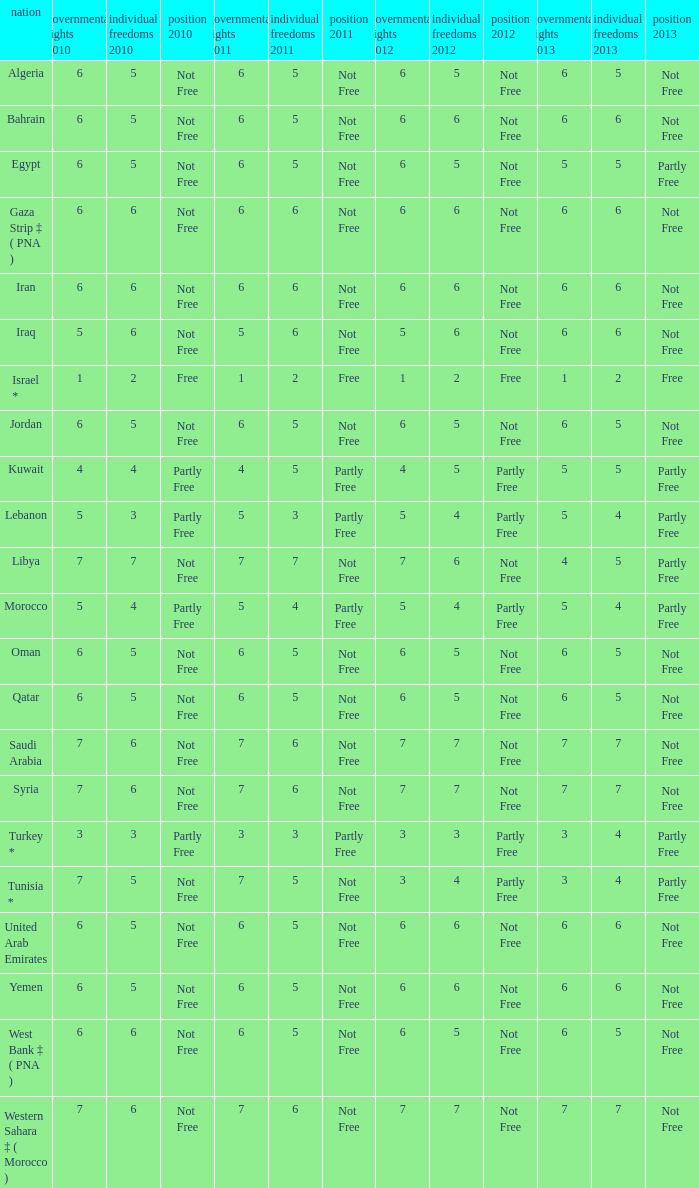What is the total number of civil liberties 2011 values having 2010 political rights values under 3 and 2011 political rights values under 1? 0.0. 